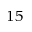<formula> <loc_0><loc_0><loc_500><loc_500>^ { 1 5 }</formula> 